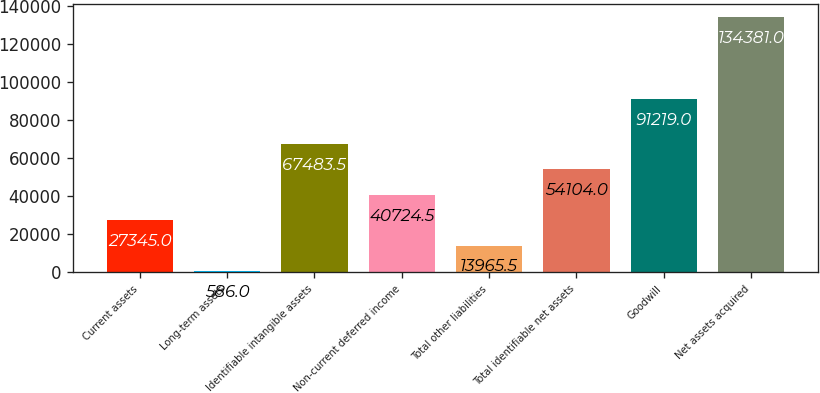Convert chart. <chart><loc_0><loc_0><loc_500><loc_500><bar_chart><fcel>Current assets<fcel>Long-term assets<fcel>Identifiable intangible assets<fcel>Non-current deferred income<fcel>Total other liabilities<fcel>Total identifiable net assets<fcel>Goodwill<fcel>Net assets acquired<nl><fcel>27345<fcel>586<fcel>67483.5<fcel>40724.5<fcel>13965.5<fcel>54104<fcel>91219<fcel>134381<nl></chart> 